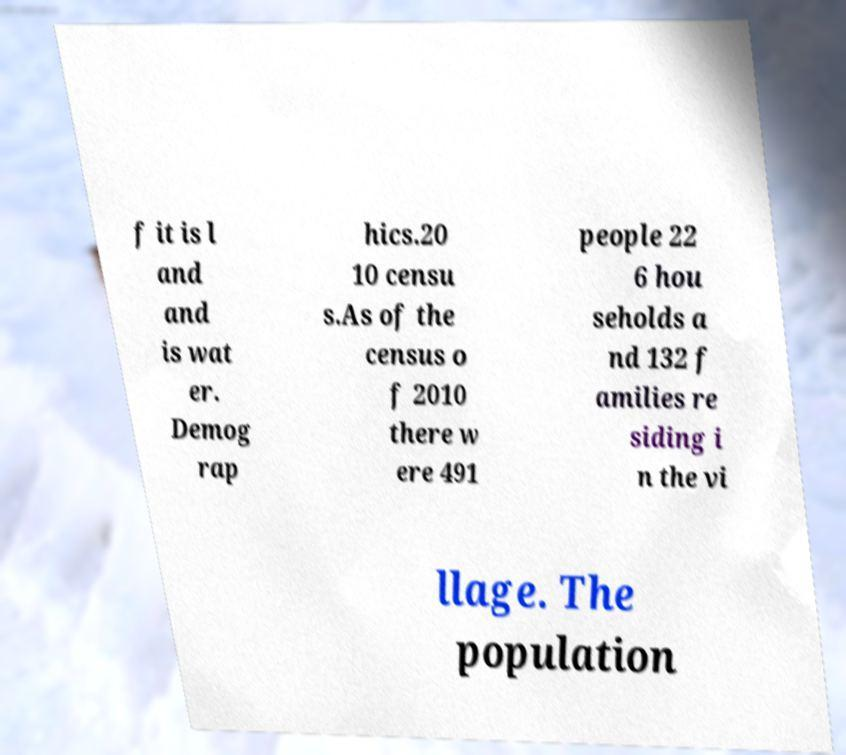Could you assist in decoding the text presented in this image and type it out clearly? f it is l and and is wat er. Demog rap hics.20 10 censu s.As of the census o f 2010 there w ere 491 people 22 6 hou seholds a nd 132 f amilies re siding i n the vi llage. The population 